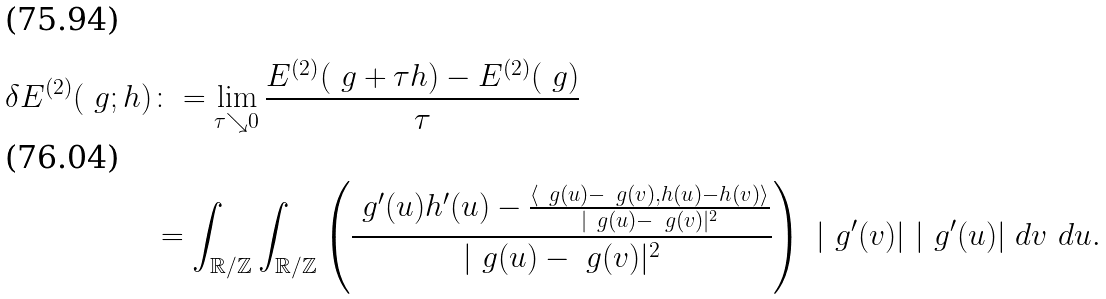<formula> <loc_0><loc_0><loc_500><loc_500>\delta E ^ { ( 2 ) } ( \ g ; h ) & \colon = \lim _ { \tau \searrow 0 } \frac { E ^ { ( 2 ) } ( \ g + \tau h ) - E ^ { ( 2 ) } ( \ g ) } \tau \\ & = \int _ { \mathbb { R } / \mathbb { Z } } \int _ { \mathbb { R } / \mathbb { Z } } \left ( \frac { \ g ^ { \prime } ( u ) h ^ { \prime } ( u ) - \frac { \left \langle \ g ( u ) - \ g ( v ) , h ( u ) - h ( v ) \right \rangle } { | \ g ( u ) - \ g ( v ) | ^ { 2 } } } { | \ g ( u ) - \ g ( v ) | ^ { 2 } } \right ) \ | \ g ^ { \prime } ( v ) | \ | \ g ^ { \prime } ( u ) | \ d v \ d u .</formula> 